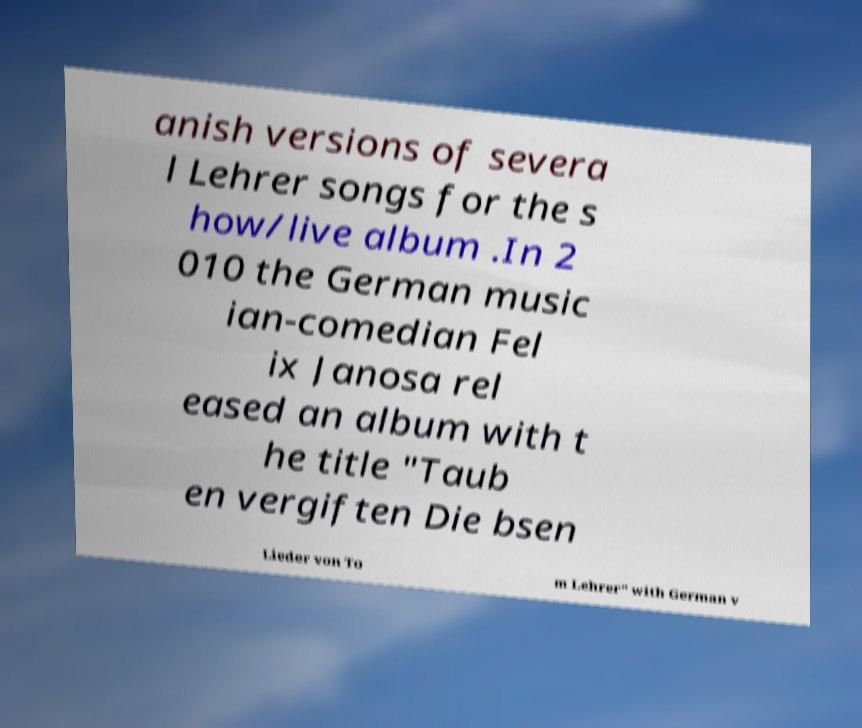Could you assist in decoding the text presented in this image and type it out clearly? anish versions of severa l Lehrer songs for the s how/live album .In 2 010 the German music ian-comedian Fel ix Janosa rel eased an album with t he title "Taub en vergiften Die bsen Lieder von To m Lehrer" with German v 